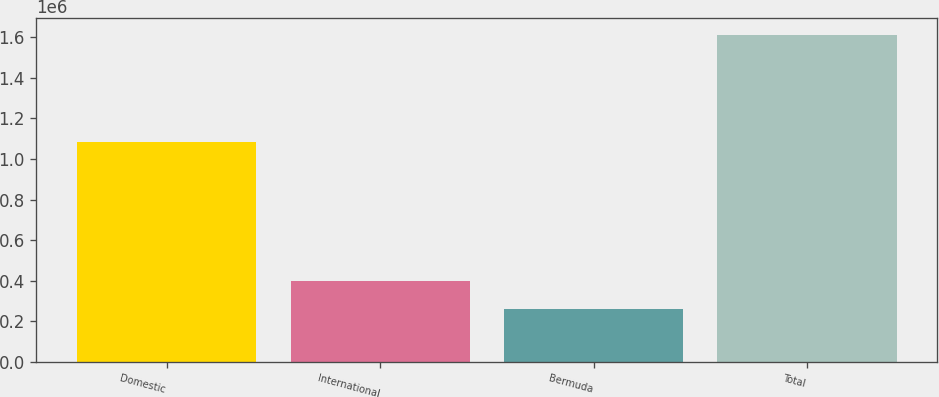Convert chart to OTSL. <chart><loc_0><loc_0><loc_500><loc_500><bar_chart><fcel>Domestic<fcel>International<fcel>Bermuda<fcel>Total<nl><fcel>1.08453e+06<fcel>396906<fcel>261741<fcel>1.61339e+06<nl></chart> 